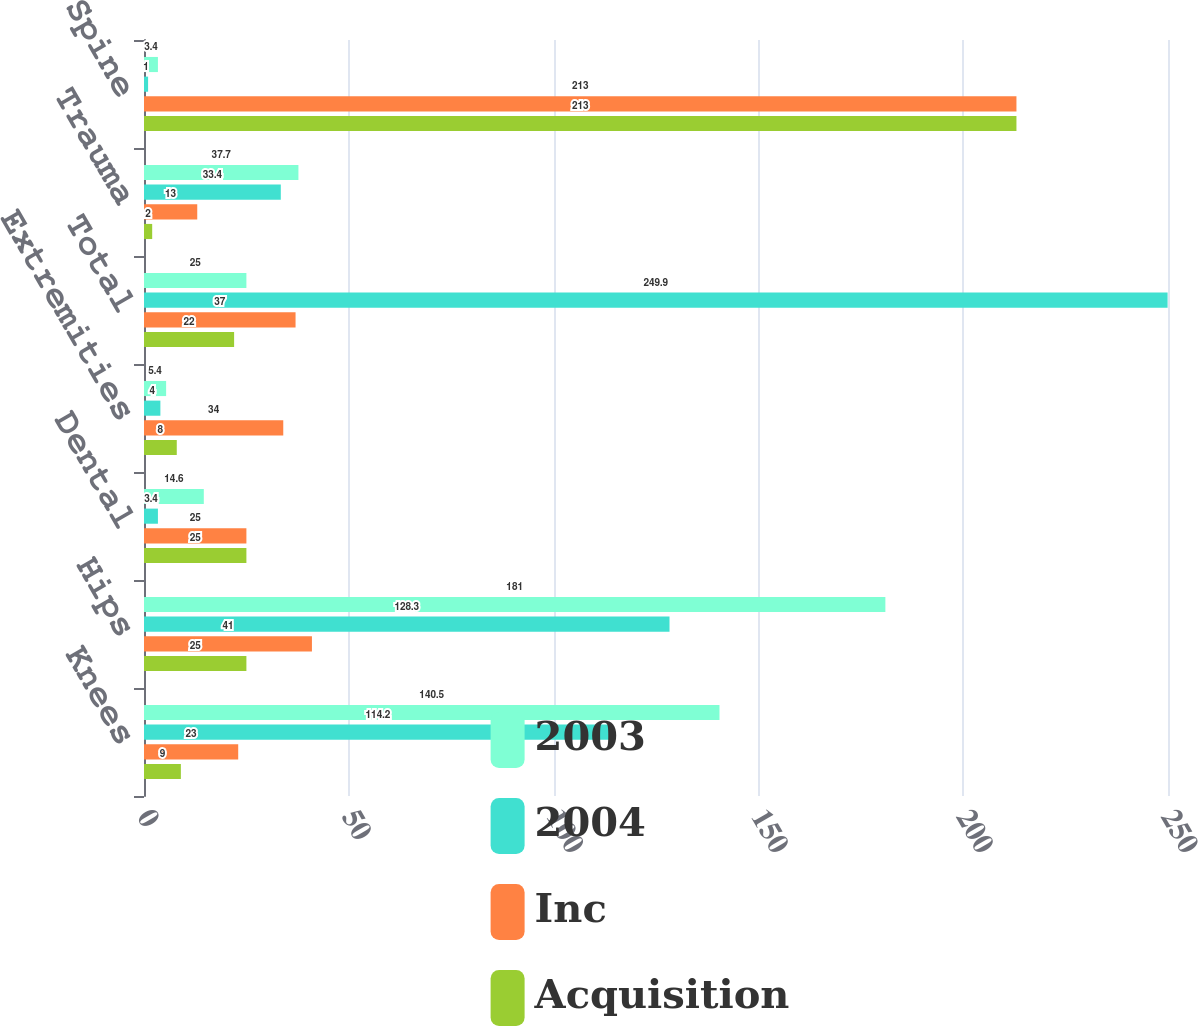Convert chart. <chart><loc_0><loc_0><loc_500><loc_500><stacked_bar_chart><ecel><fcel>Knees<fcel>Hips<fcel>Dental<fcel>Extremities<fcel>Total<fcel>Trauma<fcel>Spine<nl><fcel>2003<fcel>140.5<fcel>181<fcel>14.6<fcel>5.4<fcel>25<fcel>37.7<fcel>3.4<nl><fcel>2004<fcel>114.2<fcel>128.3<fcel>3.4<fcel>4<fcel>249.9<fcel>33.4<fcel>1<nl><fcel>Inc<fcel>23<fcel>41<fcel>25<fcel>34<fcel>37<fcel>13<fcel>213<nl><fcel>Acquisition<fcel>9<fcel>25<fcel>25<fcel>8<fcel>22<fcel>2<fcel>213<nl></chart> 